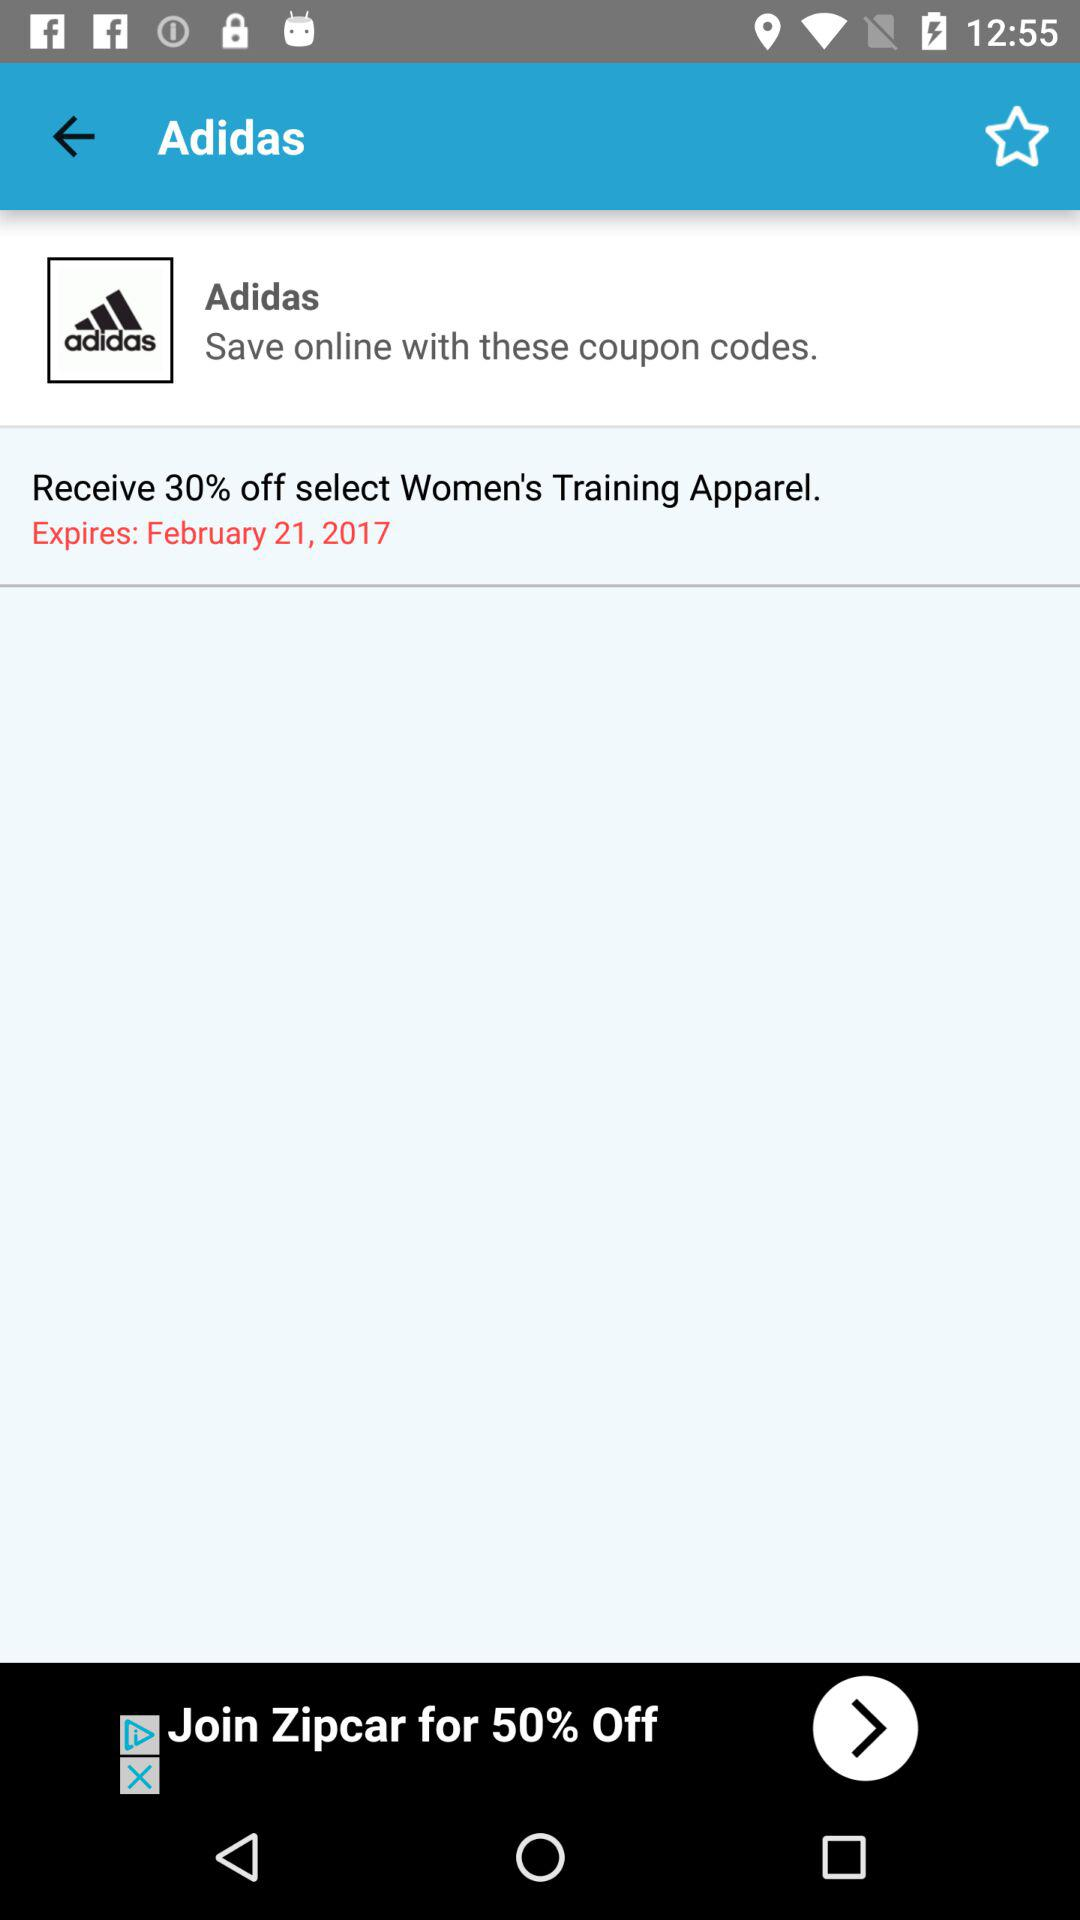When will the coupon expire? The coupon will expire on February 21, 2017. 